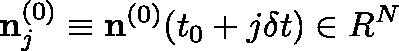<formula> <loc_0><loc_0><loc_500><loc_500>{ n } _ { j } ^ { ( 0 ) } \equiv n ^ { ( 0 ) } ( t _ { 0 } + j \delta t ) \in { \boldmath R } ^ { N }</formula> 